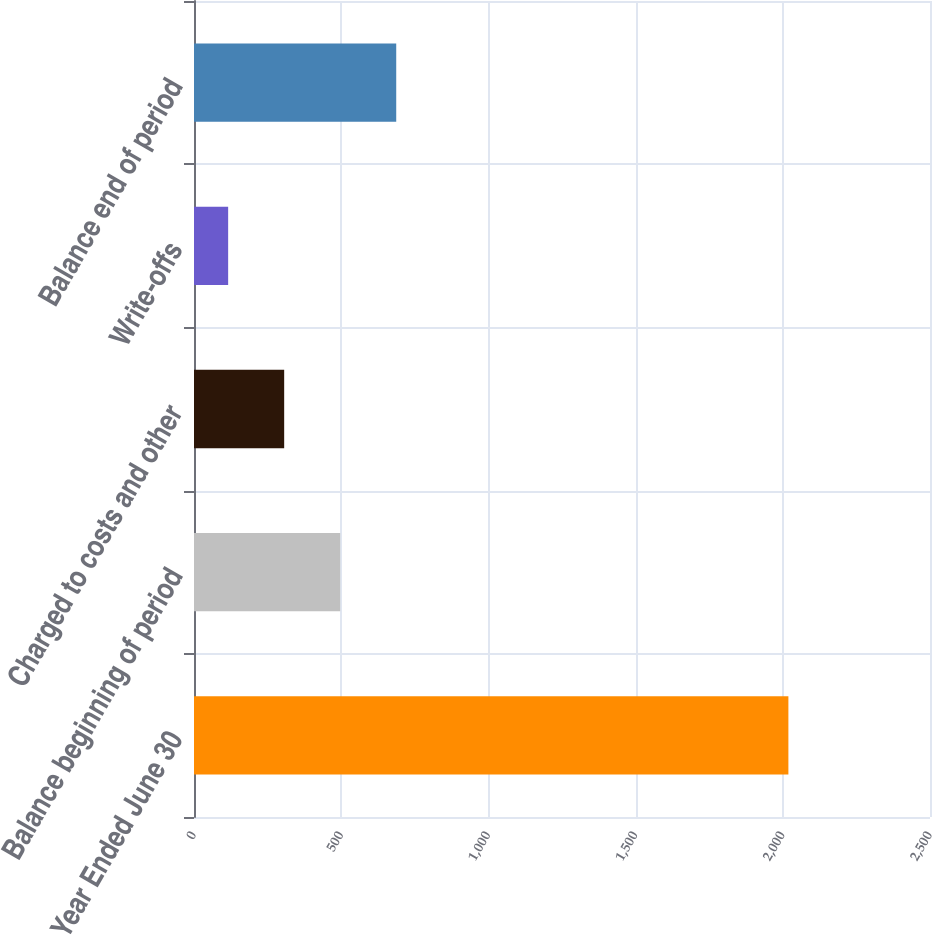Convert chart. <chart><loc_0><loc_0><loc_500><loc_500><bar_chart><fcel>Year Ended June 30<fcel>Balance beginning of period<fcel>Charged to costs and other<fcel>Write-offs<fcel>Balance end of period<nl><fcel>2019<fcel>496.6<fcel>306.3<fcel>116<fcel>686.9<nl></chart> 